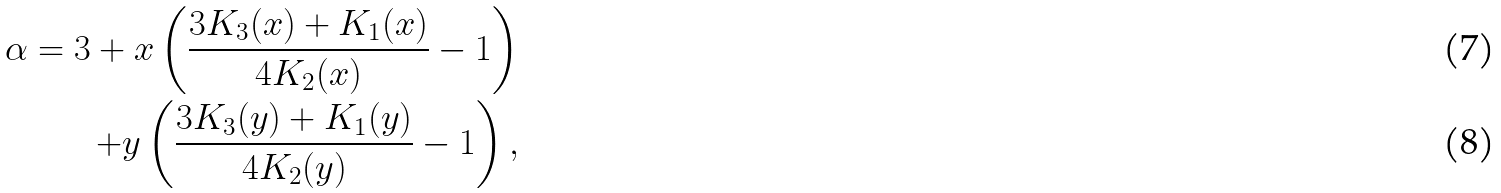<formula> <loc_0><loc_0><loc_500><loc_500>\alpha = 3 + x \left ( \frac { 3 K _ { 3 } ( x ) + K _ { 1 } ( x ) } { 4 K _ { 2 } ( x ) } - 1 \right ) \\ + y \left ( \frac { 3 K _ { 3 } ( y ) + K _ { 1 } ( y ) } { 4 K _ { 2 } ( y ) } - 1 \right ) ,</formula> 